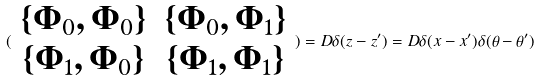Convert formula to latex. <formula><loc_0><loc_0><loc_500><loc_500>( \begin{array} { c c } \{ \Phi _ { 0 } , \Phi _ { 0 } \} & \{ \Phi _ { 0 } , \Phi _ { 1 } \} \\ \{ \Phi _ { 1 } , \Phi _ { 0 } \} & \{ \Phi _ { 1 } , \Phi _ { 1 } \} \end{array} ) = D \delta ( z - z ^ { \prime } ) = D \delta ( x - x ^ { \prime } ) \delta ( \theta - \theta ^ { \prime } )</formula> 